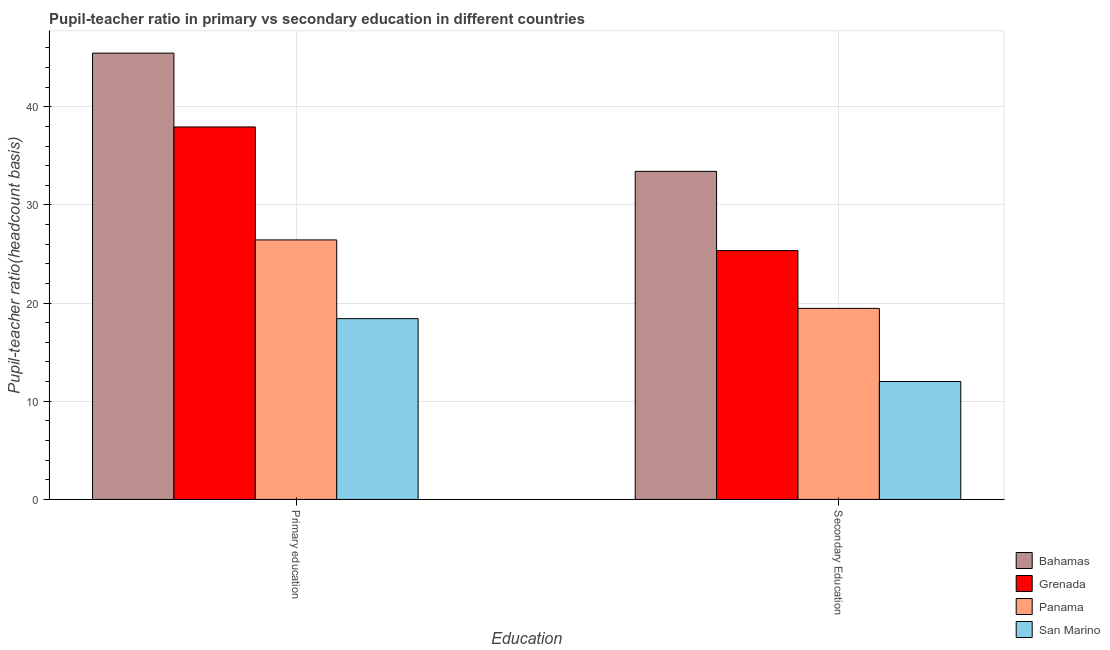How many different coloured bars are there?
Keep it short and to the point. 4. How many groups of bars are there?
Provide a short and direct response. 2. Are the number of bars per tick equal to the number of legend labels?
Make the answer very short. Yes. Are the number of bars on each tick of the X-axis equal?
Offer a terse response. Yes. What is the label of the 1st group of bars from the left?
Provide a short and direct response. Primary education. What is the pupil-teacher ratio in primary education in San Marino?
Keep it short and to the point. 18.42. Across all countries, what is the maximum pupil-teacher ratio in primary education?
Offer a very short reply. 45.46. Across all countries, what is the minimum pupil teacher ratio on secondary education?
Make the answer very short. 12.01. In which country was the pupil teacher ratio on secondary education maximum?
Offer a very short reply. Bahamas. In which country was the pupil-teacher ratio in primary education minimum?
Give a very brief answer. San Marino. What is the total pupil-teacher ratio in primary education in the graph?
Provide a short and direct response. 128.26. What is the difference between the pupil-teacher ratio in primary education in Bahamas and that in Panama?
Your answer should be very brief. 19.03. What is the difference between the pupil-teacher ratio in primary education in San Marino and the pupil teacher ratio on secondary education in Bahamas?
Your response must be concise. -15. What is the average pupil-teacher ratio in primary education per country?
Your response must be concise. 32.06. What is the difference between the pupil-teacher ratio in primary education and pupil teacher ratio on secondary education in Bahamas?
Offer a terse response. 12.04. What is the ratio of the pupil teacher ratio on secondary education in San Marino to that in Bahamas?
Keep it short and to the point. 0.36. Is the pupil-teacher ratio in primary education in Grenada less than that in Bahamas?
Your answer should be compact. Yes. What does the 2nd bar from the left in Secondary Education represents?
Keep it short and to the point. Grenada. What does the 1st bar from the right in Primary education represents?
Provide a succinct answer. San Marino. How many bars are there?
Offer a very short reply. 8. Are all the bars in the graph horizontal?
Ensure brevity in your answer.  No. How many countries are there in the graph?
Offer a very short reply. 4. Does the graph contain any zero values?
Provide a short and direct response. No. Does the graph contain grids?
Keep it short and to the point. Yes. How are the legend labels stacked?
Provide a short and direct response. Vertical. What is the title of the graph?
Ensure brevity in your answer.  Pupil-teacher ratio in primary vs secondary education in different countries. Does "North America" appear as one of the legend labels in the graph?
Make the answer very short. No. What is the label or title of the X-axis?
Make the answer very short. Education. What is the label or title of the Y-axis?
Your answer should be compact. Pupil-teacher ratio(headcount basis). What is the Pupil-teacher ratio(headcount basis) of Bahamas in Primary education?
Provide a succinct answer. 45.46. What is the Pupil-teacher ratio(headcount basis) of Grenada in Primary education?
Offer a terse response. 37.94. What is the Pupil-teacher ratio(headcount basis) of Panama in Primary education?
Make the answer very short. 26.44. What is the Pupil-teacher ratio(headcount basis) of San Marino in Primary education?
Offer a terse response. 18.42. What is the Pupil-teacher ratio(headcount basis) of Bahamas in Secondary Education?
Your response must be concise. 33.42. What is the Pupil-teacher ratio(headcount basis) of Grenada in Secondary Education?
Offer a terse response. 25.35. What is the Pupil-teacher ratio(headcount basis) of Panama in Secondary Education?
Keep it short and to the point. 19.46. What is the Pupil-teacher ratio(headcount basis) in San Marino in Secondary Education?
Give a very brief answer. 12.01. Across all Education, what is the maximum Pupil-teacher ratio(headcount basis) of Bahamas?
Your answer should be very brief. 45.46. Across all Education, what is the maximum Pupil-teacher ratio(headcount basis) of Grenada?
Offer a very short reply. 37.94. Across all Education, what is the maximum Pupil-teacher ratio(headcount basis) of Panama?
Ensure brevity in your answer.  26.44. Across all Education, what is the maximum Pupil-teacher ratio(headcount basis) in San Marino?
Provide a short and direct response. 18.42. Across all Education, what is the minimum Pupil-teacher ratio(headcount basis) in Bahamas?
Offer a very short reply. 33.42. Across all Education, what is the minimum Pupil-teacher ratio(headcount basis) in Grenada?
Provide a succinct answer. 25.35. Across all Education, what is the minimum Pupil-teacher ratio(headcount basis) of Panama?
Offer a terse response. 19.46. Across all Education, what is the minimum Pupil-teacher ratio(headcount basis) in San Marino?
Ensure brevity in your answer.  12.01. What is the total Pupil-teacher ratio(headcount basis) in Bahamas in the graph?
Your answer should be very brief. 78.88. What is the total Pupil-teacher ratio(headcount basis) of Grenada in the graph?
Ensure brevity in your answer.  63.29. What is the total Pupil-teacher ratio(headcount basis) of Panama in the graph?
Keep it short and to the point. 45.9. What is the total Pupil-teacher ratio(headcount basis) of San Marino in the graph?
Give a very brief answer. 30.43. What is the difference between the Pupil-teacher ratio(headcount basis) of Bahamas in Primary education and that in Secondary Education?
Keep it short and to the point. 12.04. What is the difference between the Pupil-teacher ratio(headcount basis) of Grenada in Primary education and that in Secondary Education?
Your response must be concise. 12.6. What is the difference between the Pupil-teacher ratio(headcount basis) in Panama in Primary education and that in Secondary Education?
Offer a terse response. 6.97. What is the difference between the Pupil-teacher ratio(headcount basis) of San Marino in Primary education and that in Secondary Education?
Make the answer very short. 6.4. What is the difference between the Pupil-teacher ratio(headcount basis) of Bahamas in Primary education and the Pupil-teacher ratio(headcount basis) of Grenada in Secondary Education?
Give a very brief answer. 20.11. What is the difference between the Pupil-teacher ratio(headcount basis) in Bahamas in Primary education and the Pupil-teacher ratio(headcount basis) in Panama in Secondary Education?
Your answer should be very brief. 26. What is the difference between the Pupil-teacher ratio(headcount basis) of Bahamas in Primary education and the Pupil-teacher ratio(headcount basis) of San Marino in Secondary Education?
Keep it short and to the point. 33.45. What is the difference between the Pupil-teacher ratio(headcount basis) of Grenada in Primary education and the Pupil-teacher ratio(headcount basis) of Panama in Secondary Education?
Offer a very short reply. 18.48. What is the difference between the Pupil-teacher ratio(headcount basis) in Grenada in Primary education and the Pupil-teacher ratio(headcount basis) in San Marino in Secondary Education?
Your response must be concise. 25.93. What is the difference between the Pupil-teacher ratio(headcount basis) in Panama in Primary education and the Pupil-teacher ratio(headcount basis) in San Marino in Secondary Education?
Your answer should be compact. 14.42. What is the average Pupil-teacher ratio(headcount basis) in Bahamas per Education?
Provide a short and direct response. 39.44. What is the average Pupil-teacher ratio(headcount basis) of Grenada per Education?
Your answer should be very brief. 31.65. What is the average Pupil-teacher ratio(headcount basis) of Panama per Education?
Keep it short and to the point. 22.95. What is the average Pupil-teacher ratio(headcount basis) of San Marino per Education?
Provide a short and direct response. 15.21. What is the difference between the Pupil-teacher ratio(headcount basis) in Bahamas and Pupil-teacher ratio(headcount basis) in Grenada in Primary education?
Ensure brevity in your answer.  7.52. What is the difference between the Pupil-teacher ratio(headcount basis) of Bahamas and Pupil-teacher ratio(headcount basis) of Panama in Primary education?
Provide a succinct answer. 19.03. What is the difference between the Pupil-teacher ratio(headcount basis) of Bahamas and Pupil-teacher ratio(headcount basis) of San Marino in Primary education?
Offer a very short reply. 27.05. What is the difference between the Pupil-teacher ratio(headcount basis) of Grenada and Pupil-teacher ratio(headcount basis) of Panama in Primary education?
Ensure brevity in your answer.  11.51. What is the difference between the Pupil-teacher ratio(headcount basis) in Grenada and Pupil-teacher ratio(headcount basis) in San Marino in Primary education?
Make the answer very short. 19.53. What is the difference between the Pupil-teacher ratio(headcount basis) in Panama and Pupil-teacher ratio(headcount basis) in San Marino in Primary education?
Offer a very short reply. 8.02. What is the difference between the Pupil-teacher ratio(headcount basis) of Bahamas and Pupil-teacher ratio(headcount basis) of Grenada in Secondary Education?
Your response must be concise. 8.07. What is the difference between the Pupil-teacher ratio(headcount basis) of Bahamas and Pupil-teacher ratio(headcount basis) of Panama in Secondary Education?
Your response must be concise. 13.96. What is the difference between the Pupil-teacher ratio(headcount basis) in Bahamas and Pupil-teacher ratio(headcount basis) in San Marino in Secondary Education?
Offer a terse response. 21.41. What is the difference between the Pupil-teacher ratio(headcount basis) of Grenada and Pupil-teacher ratio(headcount basis) of Panama in Secondary Education?
Your response must be concise. 5.89. What is the difference between the Pupil-teacher ratio(headcount basis) in Grenada and Pupil-teacher ratio(headcount basis) in San Marino in Secondary Education?
Give a very brief answer. 13.33. What is the difference between the Pupil-teacher ratio(headcount basis) of Panama and Pupil-teacher ratio(headcount basis) of San Marino in Secondary Education?
Keep it short and to the point. 7.45. What is the ratio of the Pupil-teacher ratio(headcount basis) in Bahamas in Primary education to that in Secondary Education?
Ensure brevity in your answer.  1.36. What is the ratio of the Pupil-teacher ratio(headcount basis) in Grenada in Primary education to that in Secondary Education?
Your answer should be compact. 1.5. What is the ratio of the Pupil-teacher ratio(headcount basis) in Panama in Primary education to that in Secondary Education?
Ensure brevity in your answer.  1.36. What is the ratio of the Pupil-teacher ratio(headcount basis) of San Marino in Primary education to that in Secondary Education?
Give a very brief answer. 1.53. What is the difference between the highest and the second highest Pupil-teacher ratio(headcount basis) in Bahamas?
Your answer should be very brief. 12.04. What is the difference between the highest and the second highest Pupil-teacher ratio(headcount basis) in Grenada?
Provide a succinct answer. 12.6. What is the difference between the highest and the second highest Pupil-teacher ratio(headcount basis) in Panama?
Your answer should be compact. 6.97. What is the difference between the highest and the second highest Pupil-teacher ratio(headcount basis) of San Marino?
Your answer should be very brief. 6.4. What is the difference between the highest and the lowest Pupil-teacher ratio(headcount basis) in Bahamas?
Provide a short and direct response. 12.04. What is the difference between the highest and the lowest Pupil-teacher ratio(headcount basis) of Grenada?
Your response must be concise. 12.6. What is the difference between the highest and the lowest Pupil-teacher ratio(headcount basis) in Panama?
Provide a short and direct response. 6.97. What is the difference between the highest and the lowest Pupil-teacher ratio(headcount basis) of San Marino?
Provide a short and direct response. 6.4. 